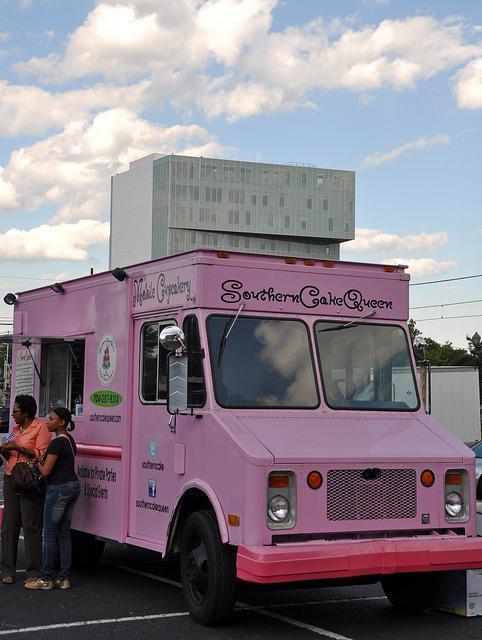How many people are standing around the truck?
Give a very brief answer. 2. How many people can you see?
Give a very brief answer. 2. How many orange boats are there?
Give a very brief answer. 0. 